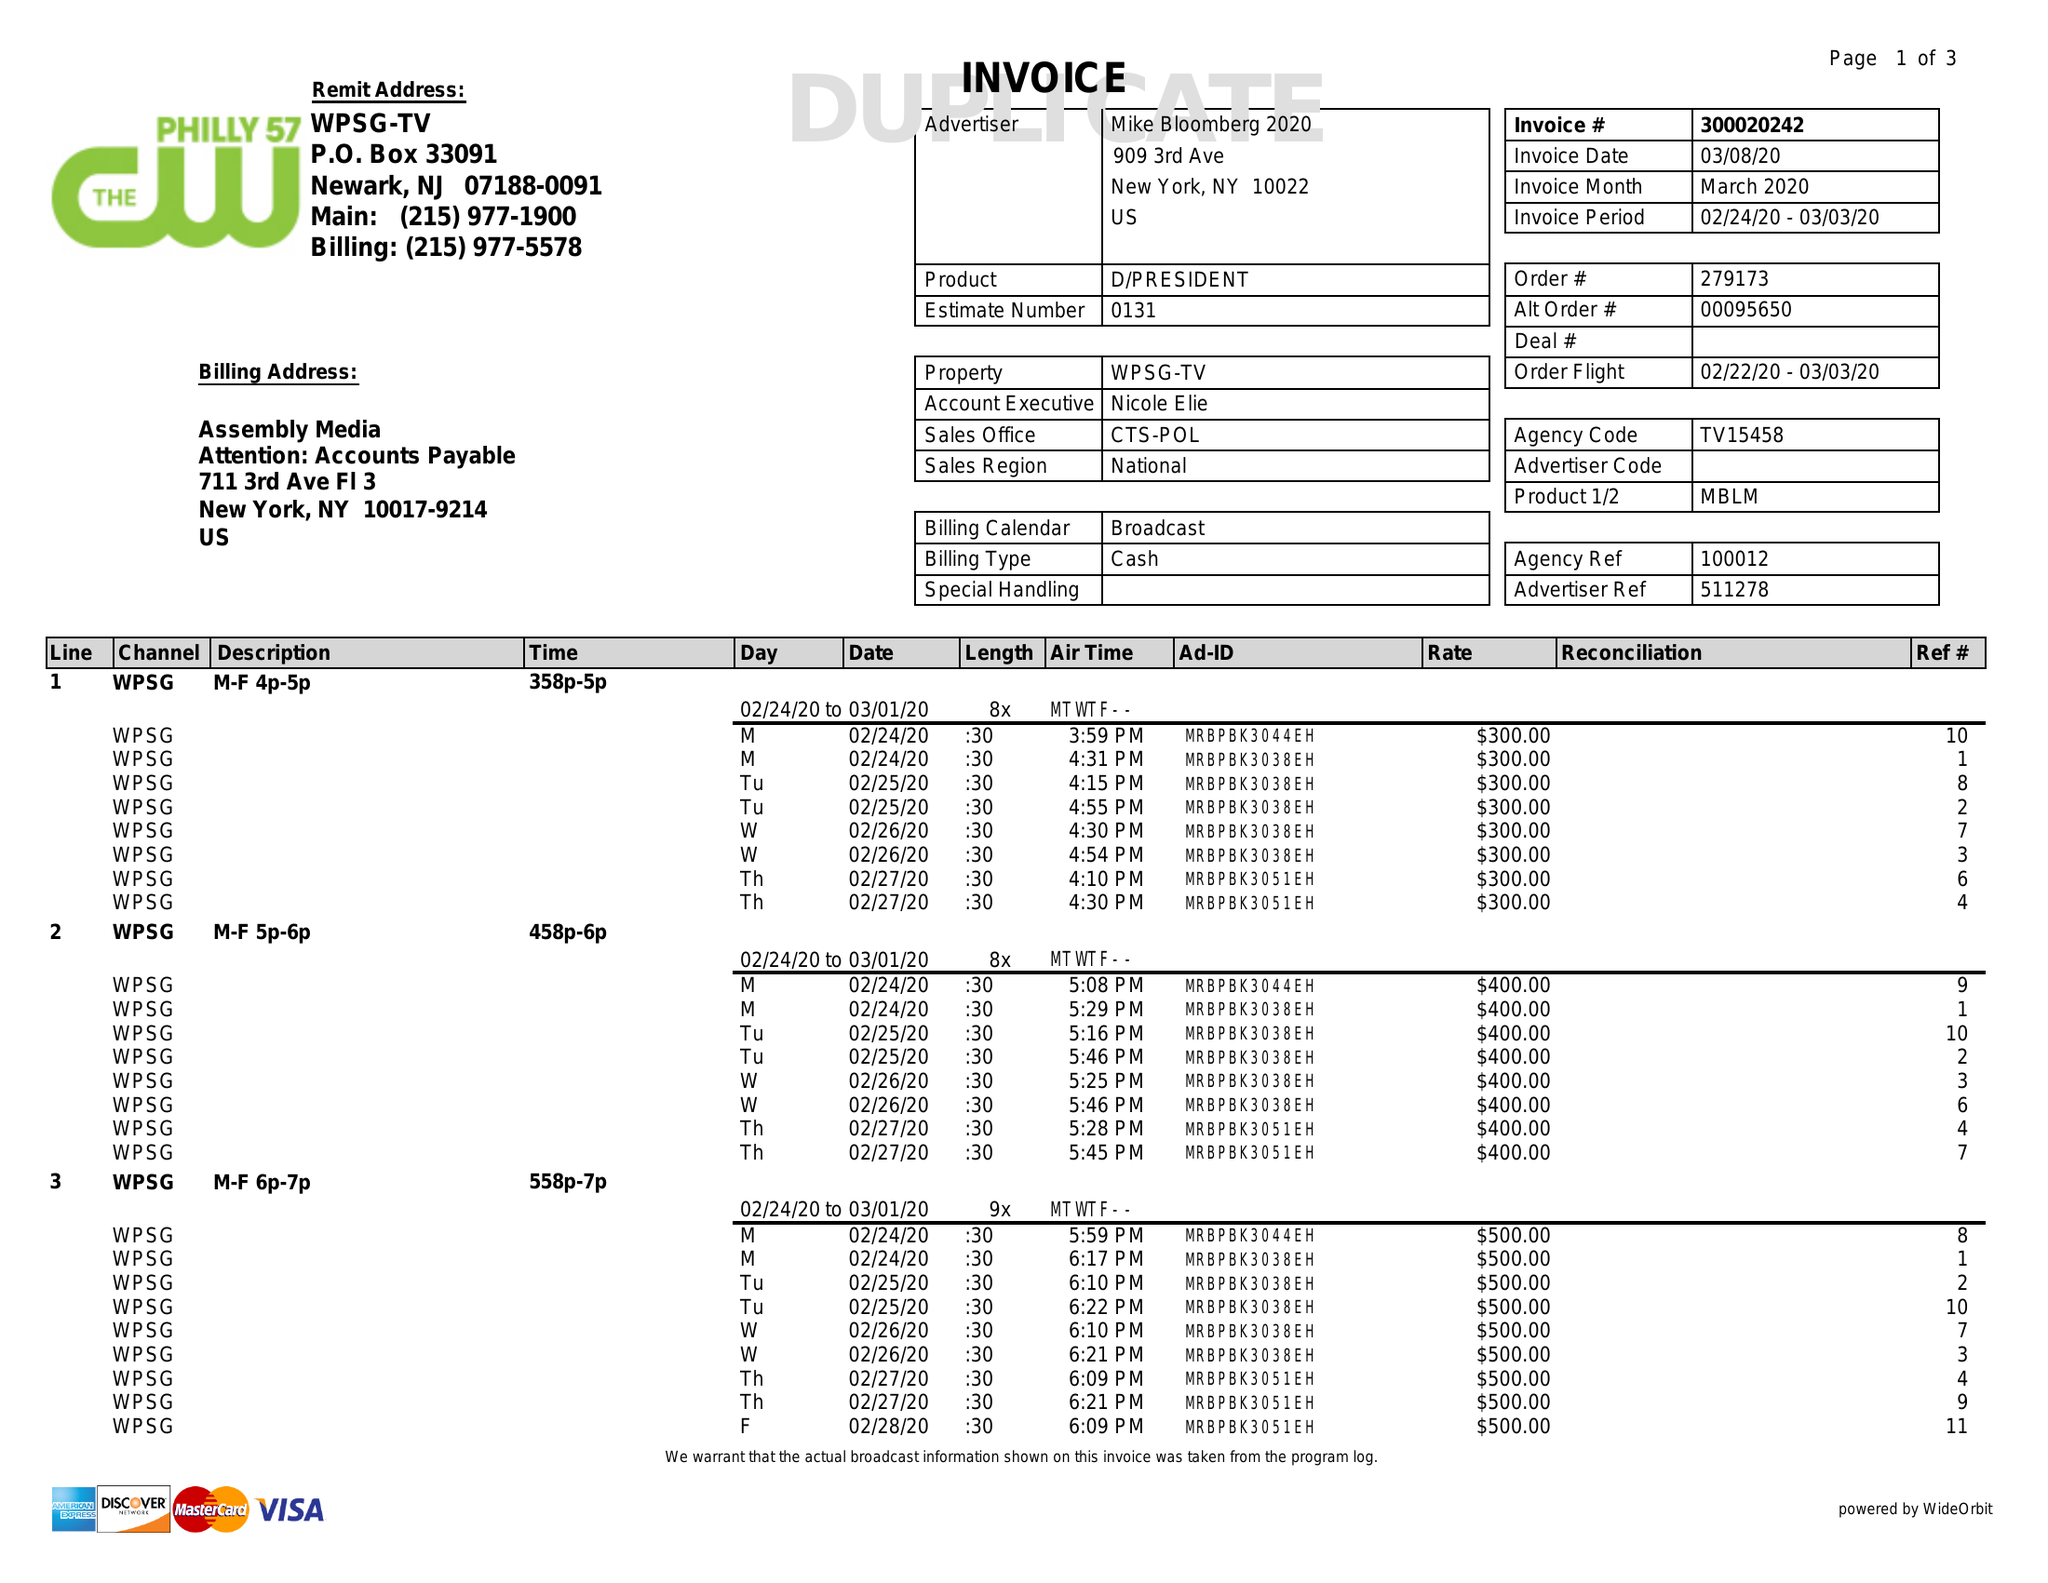What is the value for the contract_num?
Answer the question using a single word or phrase. 300020242 